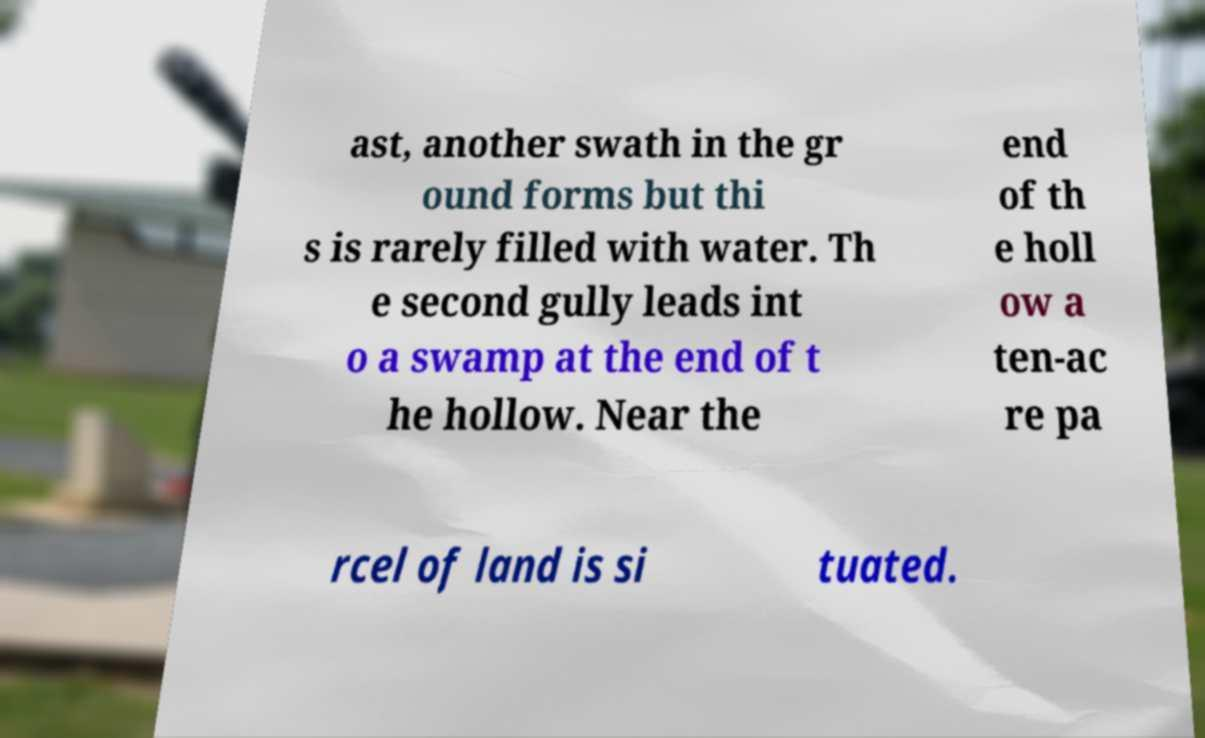Can you accurately transcribe the text from the provided image for me? ast, another swath in the gr ound forms but thi s is rarely filled with water. Th e second gully leads int o a swamp at the end of t he hollow. Near the end of th e holl ow a ten-ac re pa rcel of land is si tuated. 